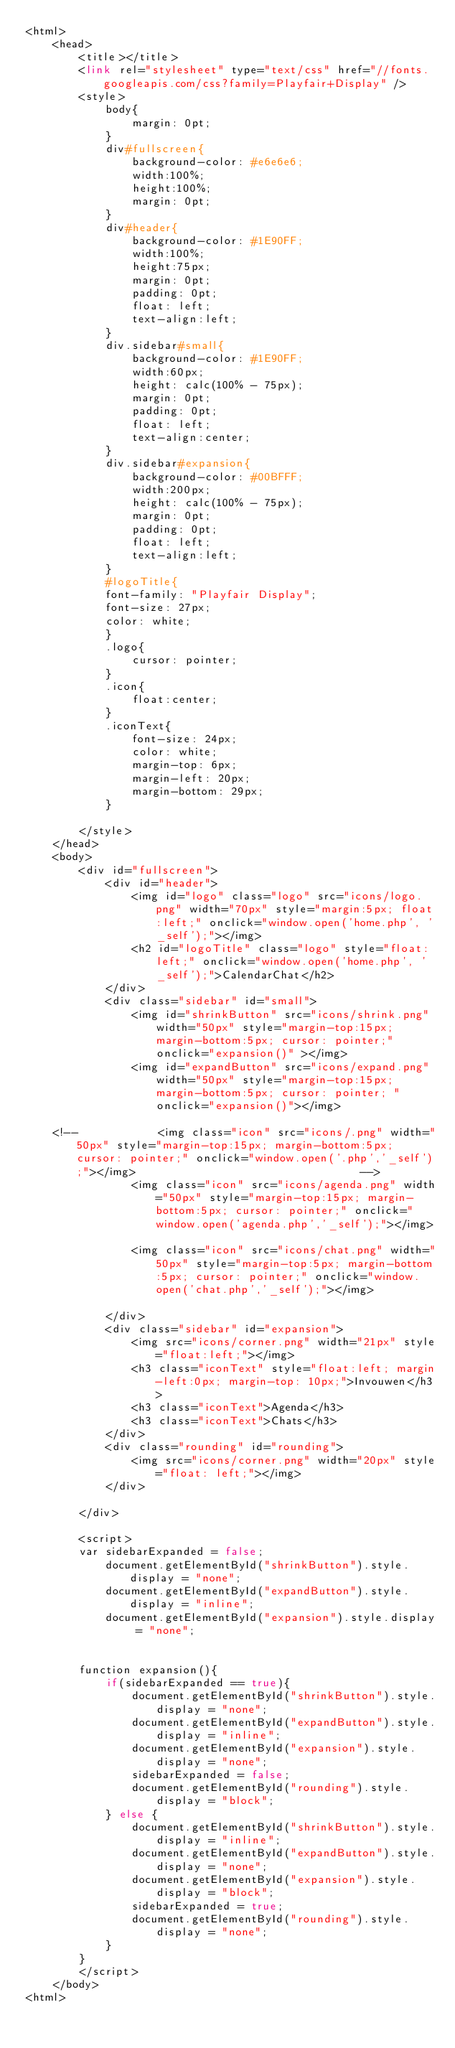Convert code to text. <code><loc_0><loc_0><loc_500><loc_500><_PHP_><html>
	<head>
		<title></title>
		<link rel="stylesheet" type="text/css" href="//fonts.googleapis.com/css?family=Playfair+Display" />
		<style>
			body{
				margin: 0pt;
			}
			div#fullscreen{
				background-color: #e6e6e6;
				width:100%; 
				height:100%; 
				margin: 0pt;
			}
			div#header{
				background-color: #1E90FF;
				width:100%;
				height:75px;
				margin: 0pt;
				padding: 0pt;
				float: left;
				text-align:left;
			}
			div.sidebar#small{
				background-color: #1E90FF;
				width:60px;
				height: calc(100% - 75px);
				margin: 0pt;
				padding: 0pt;
				float: left;
				text-align:center;
			}
			div.sidebar#expansion{
				background-color: #00BFFF;
				width:200px;
				height: calc(100% - 75px);
				margin: 0pt;
				padding: 0pt;
				float: left;
				text-align:left;
			}
			#logoTitle{
			font-family: "Playfair Display";
			font-size: 27px;
			color: white;
			}
			.logo{
				cursor: pointer;
			}
			.icon{
				float:center;
			}
			.iconText{
				font-size: 24px;
				color: white;
				margin-top: 6px;
				margin-left: 20px;
				margin-bottom: 29px;
			}
			
		</style>
	</head>
	<body>
		<div id="fullscreen">
			<div id="header">
				<img id="logo" class="logo" src="icons/logo.png" width="70px" style="margin:5px; float:left;" onclick="window.open('home.php', '_self');"></img>
				<h2 id="logoTitle" class="logo" style="float:left;" onclick="window.open('home.php', '_self');">CalendarChat</h2>
			</div>
			<div class="sidebar" id="small">
				<img id="shrinkButton" src="icons/shrink.png" width="50px" style="margin-top:15px; margin-bottom:5px; cursor: pointer;"onclick="expansion()" ></img>
				<img id="expandButton" src="icons/expand.png" width="50px" style="margin-top:15px; margin-bottom:5px; cursor: pointer; "onclick="expansion()"></img>
				
	<!--			<img class="icon" src="icons/.png" width="50px"	style="margin-top:15px; margin-bottom:5px; cursor: pointer;" onclick="window.open('.php','_self');"></img>									-->
				<img class="icon" src="icons/agenda.png" width="50px" style="margin-top:15px; margin-bottom:5px; cursor: pointer;" onclick="window.open('agenda.php','_self');"></img>									
				<img class="icon" src="icons/chat.png" width="50px" style="margin-top:5px; margin-bottom:5px; cursor: pointer;" onclick="window.open('chat.php','_self');"></img>									
			</div>
			<div class="sidebar" id="expansion">
				<img src="icons/corner.png" width="21px" style="float:left;"></img>	
				<h3 class="iconText" style="float:left; margin-left:0px; margin-top: 10px;">Invouwen</h3>
				<h3 class="iconText">Agenda</h3>
				<h3 class="iconText">Chats</h3>
			</div>
			<div class="rounding" id="rounding">
				<img src="icons/corner.png" width="20px" style="float: left;"></img>	
			</div>
			
		</div>
		
		<script>
		var sidebarExpanded = false;
			document.getElementById("shrinkButton").style.display = "none";
			document.getElementById("expandButton").style.display = "inline";
			document.getElementById("expansion").style.display = "none";

		
		function expansion(){
			if(sidebarExpanded == true){
				document.getElementById("shrinkButton").style.display = "none";
				document.getElementById("expandButton").style.display = "inline";
				document.getElementById("expansion").style.display = "none";
				sidebarExpanded = false;
				document.getElementById("rounding").style.display = "block";
			} else {
				document.getElementById("shrinkButton").style.display = "inline";
				document.getElementById("expandButton").style.display = "none";
				document.getElementById("expansion").style.display = "block";
				sidebarExpanded = true;
				document.getElementById("rounding").style.display = "none";
			}
		}
		</script>
	</body>
<html>	</code> 